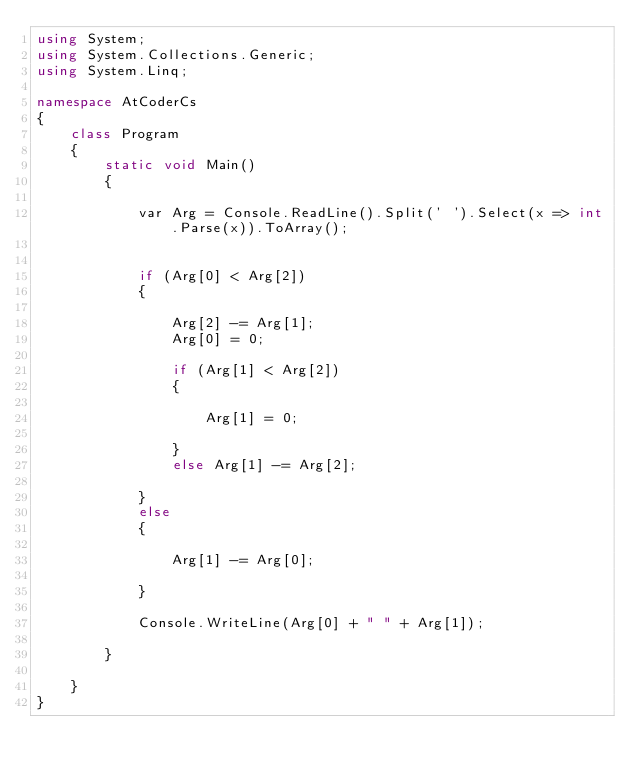<code> <loc_0><loc_0><loc_500><loc_500><_C#_>using System;
using System.Collections.Generic;
using System.Linq;

namespace AtCoderCs
{
    class Program
    {
        static void Main()
        {

            var Arg = Console.ReadLine().Split(' ').Select(x => int.Parse(x)).ToArray();


            if (Arg[0] < Arg[2])
            {

                Arg[2] -= Arg[1];
                Arg[0] = 0;

                if (Arg[1] < Arg[2])
                {

                    Arg[1] = 0;

                }
                else Arg[1] -= Arg[2];

            }
            else
            {

                Arg[1] -= Arg[0];

            }

            Console.WriteLine(Arg[0] + " " + Arg[1]);

        }

    }
}
</code> 